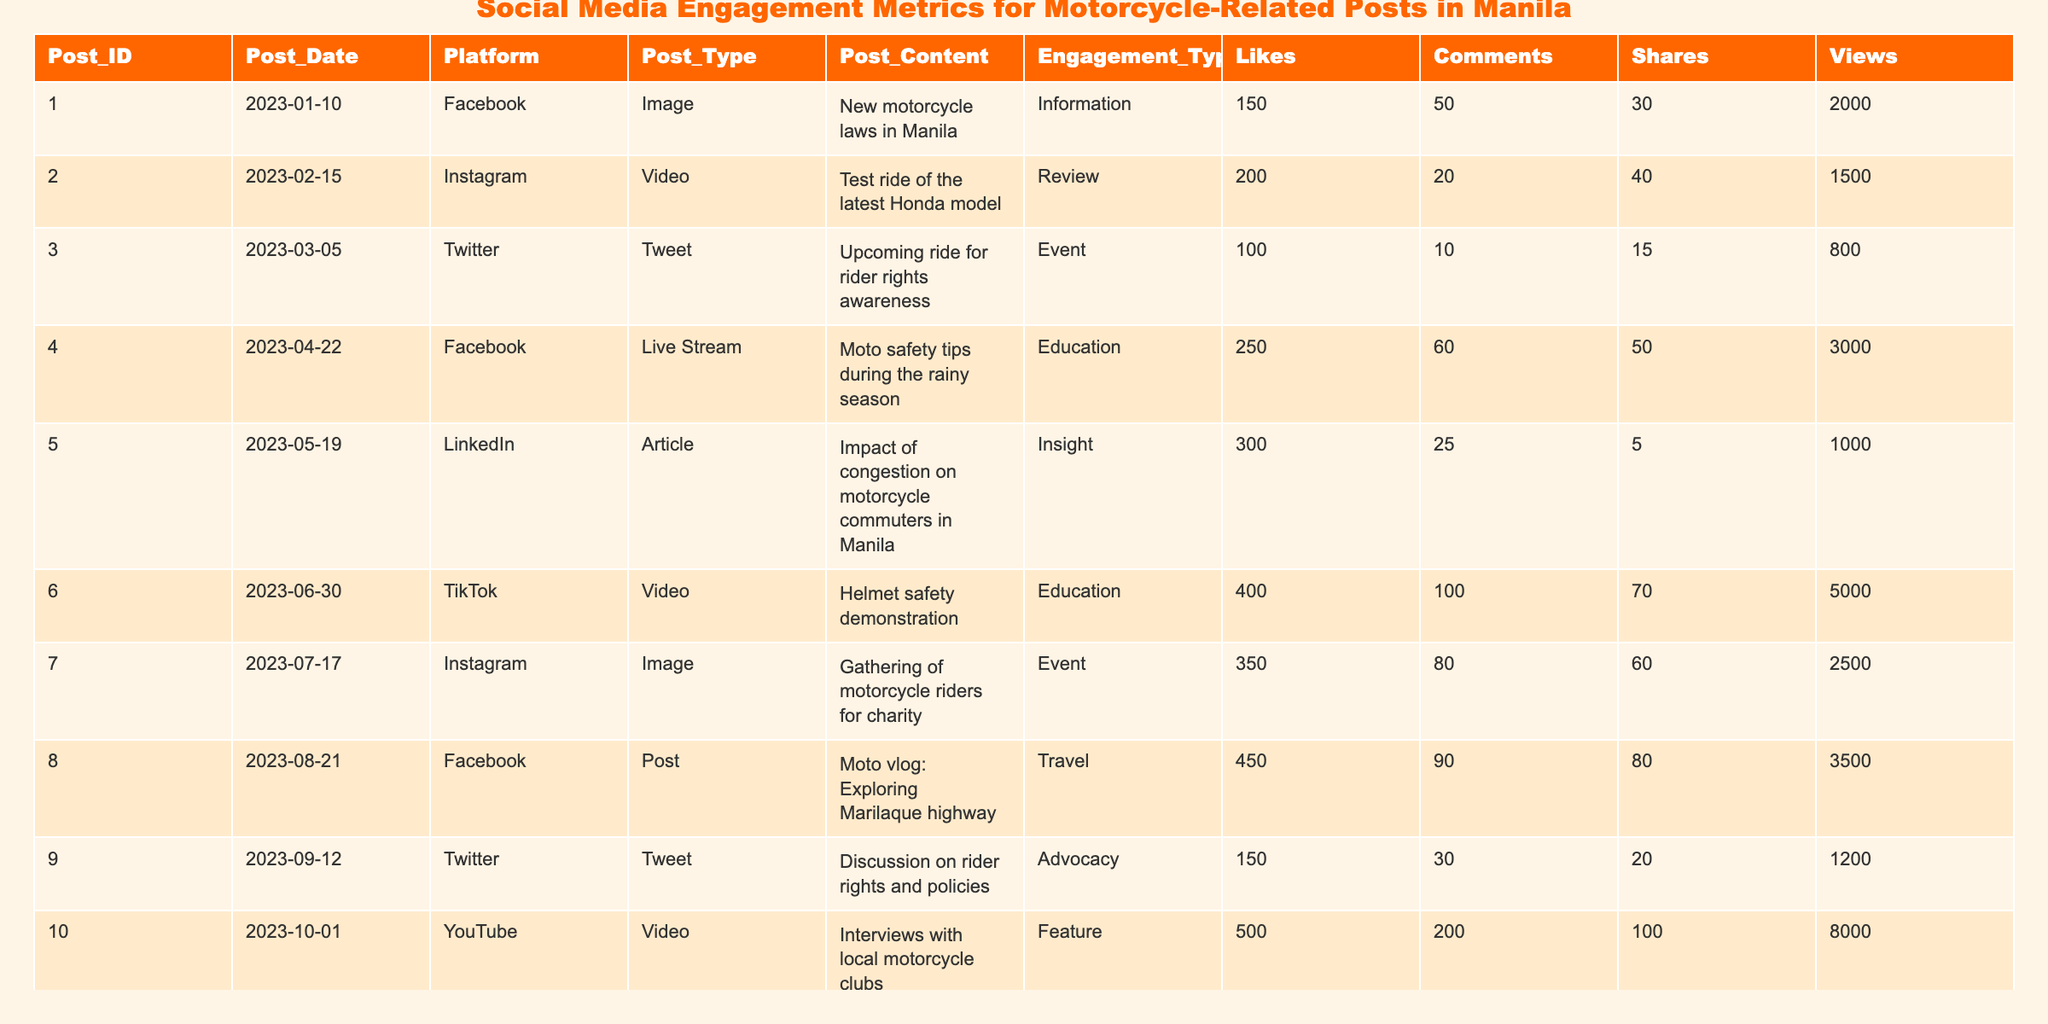What is the platform with the highest engagement in likes? Looking at the Likes column, we can see that the post on YouTube has 500 likes, which is the highest among all entries.
Answer: YouTube How many shares did the post about the helmet safety demonstration receive? Referring to the Shares column in the row for the helmet safety demonstration post, we find that it received 70 shares.
Answer: 70 Which post type had the most views overall? We can analyze the Views column by summing the views for each Post_Type. The sums are as follows: Information (2000), Review (1500), Event (3300), Education (8000), Insight (1000), and Feature (8000). Both Education and Feature have 8000 views each, with Education having more unique posts.
Answer: Education and Feature Is there any post that has more than 400 likes? Checking the Likes column reveals that the posts on YouTube (500), TikTok (400), and Instagram (450) all have more than 400 likes. Therefore, the answer is yes.
Answer: Yes What is the total number of comments received by posts related to events? From the Comments column for Event posts: the upcoming ride has 10 comments, gathering for charity has 80 comments, totaling 90 comments.
Answer: 90 Which post had the lowest engagement in terms of shares? Looking at the Shares column, the post about the impact of congestion on motorcycle commuters only got 5 shares, which is the lowest.
Answer: 5 What is the average number of views for posts on social media platforms? The total views for all posts is (2000 + 1500 + 800 + 3000 + 1000 + 5000 + 2500 + 3500 + 1200 + 8000) = 20700. There are 10 posts, so the average number of views is 20700 / 10 = 2070.
Answer: 2070 Which post received the most comments, and how many did it receive? In the Comments column, the post on YouTube has 200 comments, which is more than any other post.
Answer: YouTube, 200 Was the post regarding motorcycle laws in Manila more popular than the post discussing rider rights and policies? Comparing Likes, the motorcycle laws post received 150 likes, while the rider rights discussion received 150 as well. Thus, both posts are equally popular in this regard.
Answer: Yes, equally popular 